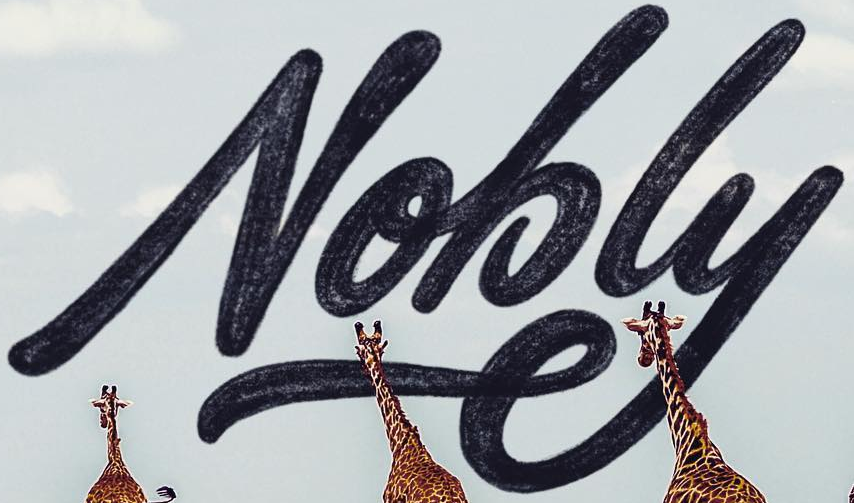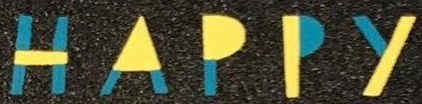Read the text content from these images in order, separated by a semicolon. Nobly; HAPPY 